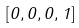<formula> <loc_0><loc_0><loc_500><loc_500>[ 0 , 0 , 0 , 1 ]</formula> 